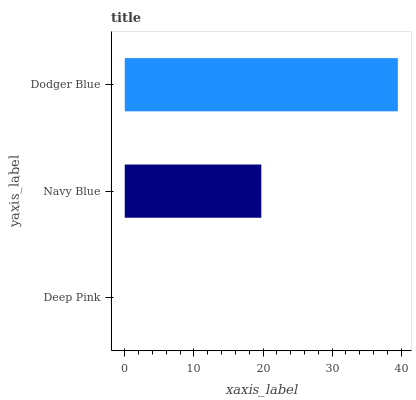Is Deep Pink the minimum?
Answer yes or no. Yes. Is Dodger Blue the maximum?
Answer yes or no. Yes. Is Navy Blue the minimum?
Answer yes or no. No. Is Navy Blue the maximum?
Answer yes or no. No. Is Navy Blue greater than Deep Pink?
Answer yes or no. Yes. Is Deep Pink less than Navy Blue?
Answer yes or no. Yes. Is Deep Pink greater than Navy Blue?
Answer yes or no. No. Is Navy Blue less than Deep Pink?
Answer yes or no. No. Is Navy Blue the high median?
Answer yes or no. Yes. Is Navy Blue the low median?
Answer yes or no. Yes. Is Deep Pink the high median?
Answer yes or no. No. Is Deep Pink the low median?
Answer yes or no. No. 